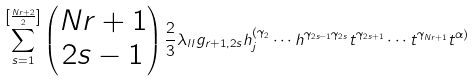Convert formula to latex. <formula><loc_0><loc_0><loc_500><loc_500>\sum _ { s = 1 } ^ { \left [ \frac { N r + 2 } { 2 } \right ] } \begin{pmatrix} N r + 1 \\ 2 s - 1 \end{pmatrix} \frac { 2 } { 3 } \lambda _ { l l } g _ { r + 1 , 2 s } h _ { j } ^ { ( \gamma _ { 2 } } \cdots h ^ { \gamma _ { 2 s - 1 } \gamma _ { 2 s } } t ^ { \gamma _ { 2 s + 1 } } \cdots t ^ { \gamma _ { N r + 1 } } t ^ { \alpha ) }</formula> 